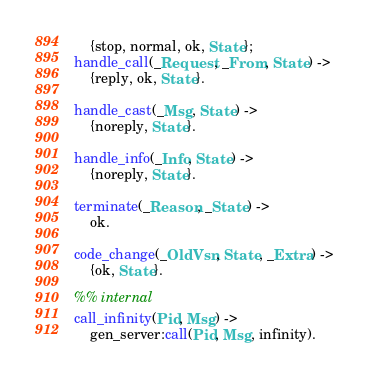Convert code to text. <code><loc_0><loc_0><loc_500><loc_500><_Erlang_>    {stop, normal, ok, State};
handle_call(_Request, _From, State) ->
    {reply, ok, State}.

handle_cast(_Msg, State) ->
    {noreply, State}.

handle_info(_Info, State) ->
    {noreply, State}.

terminate(_Reason, _State) ->
    ok.

code_change(_OldVsn, State, _Extra) ->
    {ok, State}.

%% internal
call_infinity(Pid, Msg) ->
    gen_server:call(Pid, Msg, infinity).
</code> 